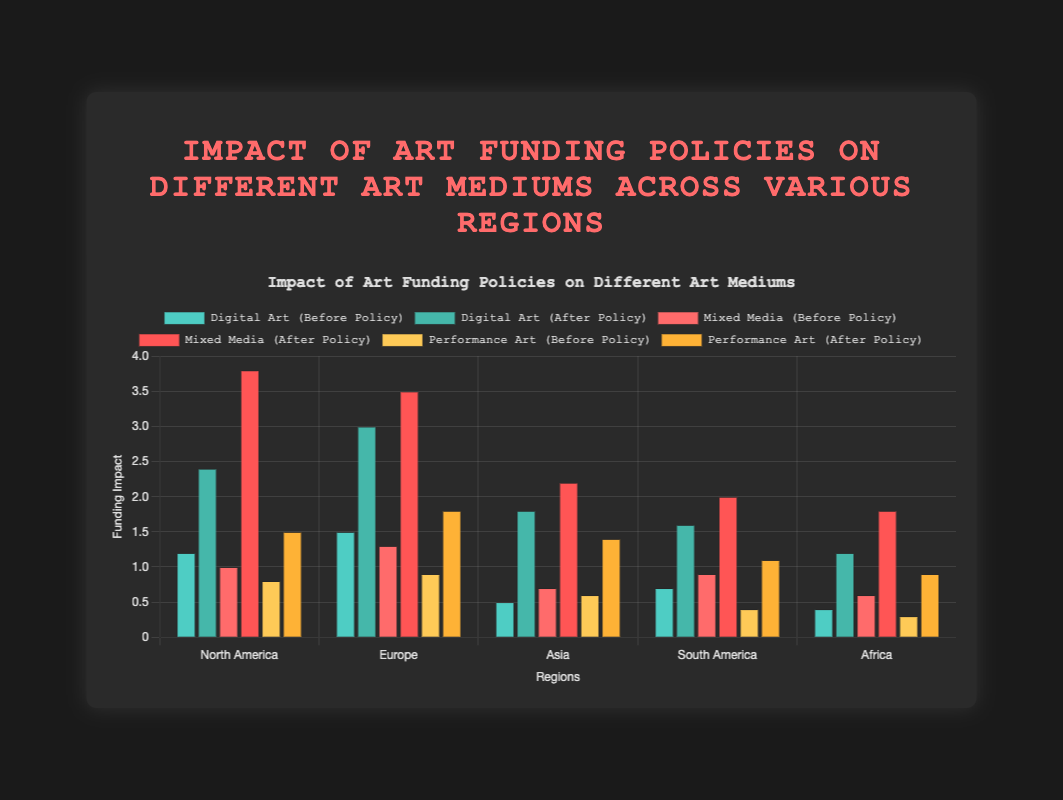Which region saw the greatest increase in funding for Mixed Media after the policy change? In order to determine the region with the greatest increase in funding for Mixed Media, subtract the "beforePolicy" value from the "afterPolicy" value for each region: North America (3.8 - 1.0 = 2.8), Europe (3.5 - 1.3 = 2.2), Asia (2.2 - 0.7 = 1.5), South America (2.0 - 0.9 = 1.1), Africa (1.8 - 0.6 = 1.2). North America has the highest increase of 2.8.
Answer: North America Which art medium in Europe had the highest funding after the policy change? To find the highest funded art medium after the policy change in Europe, compare the "afterPolicy" values for Digital Art (3.0), Mixed Media (3.5), and Performance Art (1.8). Mixed Media has the highest value of 3.5.
Answer: Mixed Media What was the total funding before the policy for all art mediums in Asia? Add the "beforePolicy" values for Digital Art (0.5), Mixed Media (0.7), and Performance Art (0.6) in Asia. The total is 0.5 + 0.7 + 0.6 = 1.8.
Answer: 1.8 Compare the funding change for Performance Art in Africa to South America. Which region saw a larger increase? Calculate the difference in funding using "afterPolicy" minus "beforePolicy" for Performance Art in Africa (0.9 - 0.3 = 0.6) and South America (1.1 - 0.4 = 0.7). South America saw a larger increase of 0.7.
Answer: South America Which region experienced the lowest funding increase for Digital Art after the policy change? Subtract "beforePolicy" from "afterPolicy" for Digital Art in each region and compare: North America (2.4 - 1.2 = 1.2), Europe (3.0 - 1.5 = 1.5), Asia (1.8 - 0.5 = 1.3), South America (1.6 - 0.7 = 0.9), Africa (1.2 - 0.4 = 0.8). Africa has the lowest increase of 0.8.
Answer: Africa What is the average increase in funding for Mixed Media across all regions? Find the increase for each region for Mixed Media (North America: 2.8, Europe: 2.2, Asia: 1.5, South America: 1.1, Africa: 1.2) and calculate the average. Sum up the increases: 2.8 + 2.2 + 1.5 + 1.1 + 1.2 = 8.8, then divide by 5 (number of regions): 8.8 / 5 = 1.76.
Answer: 1.76 Which art medium in North America had the smallest funding before the policy change? Compare the "beforePolicy" values in North America: Digital Art (1.2), Mixed Media (1.0), and Performance Art (0.8). Performance Art has the smallest value of 0.8.
Answer: Performance Art By how much did the total funding for all art mediums in Africa increase after the policy change? Sum the "beforePolicy" values for all mediums in Africa (0.4 + 0.6 + 0.3 = 1.3) and then sum the "afterPolicy" values (1.2 + 1.8 + 0.9 = 3.9). Subtract the total before from the total after, 3.9 - 1.3 = 2.6.
Answer: 2.6 